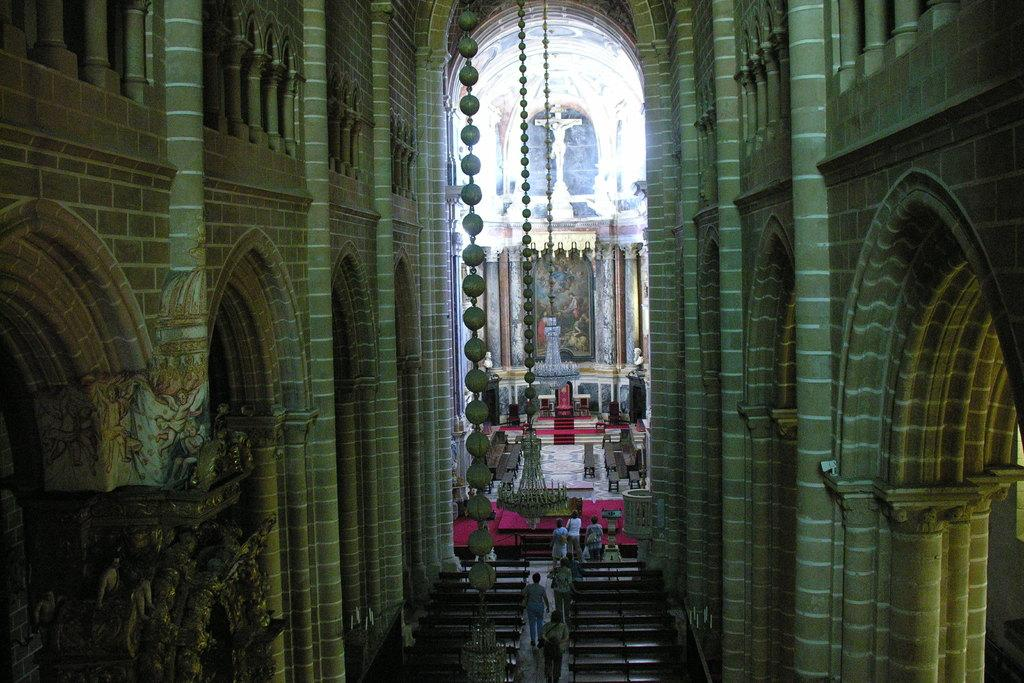What type of location is depicted in the image? The image shows an inside view of a building. Are there any people present in the image? Yes, there are people in the image. What type of furniture can be seen on the floor? There are benches on the floor. What is one architectural feature visible in the image? There is a wall visible in the image. What type of lighting is present in the image? Chandeliers are present in the image. Can you describe any other objects in the image? There are other objects in the image, but their specific details are not mentioned in the provided facts. Can you tell me how many cherries are on the person's head in the image? There is no person with cherries on their head in the image. What type of bread is being served on the benches in the image? There is no bread present in the image. 